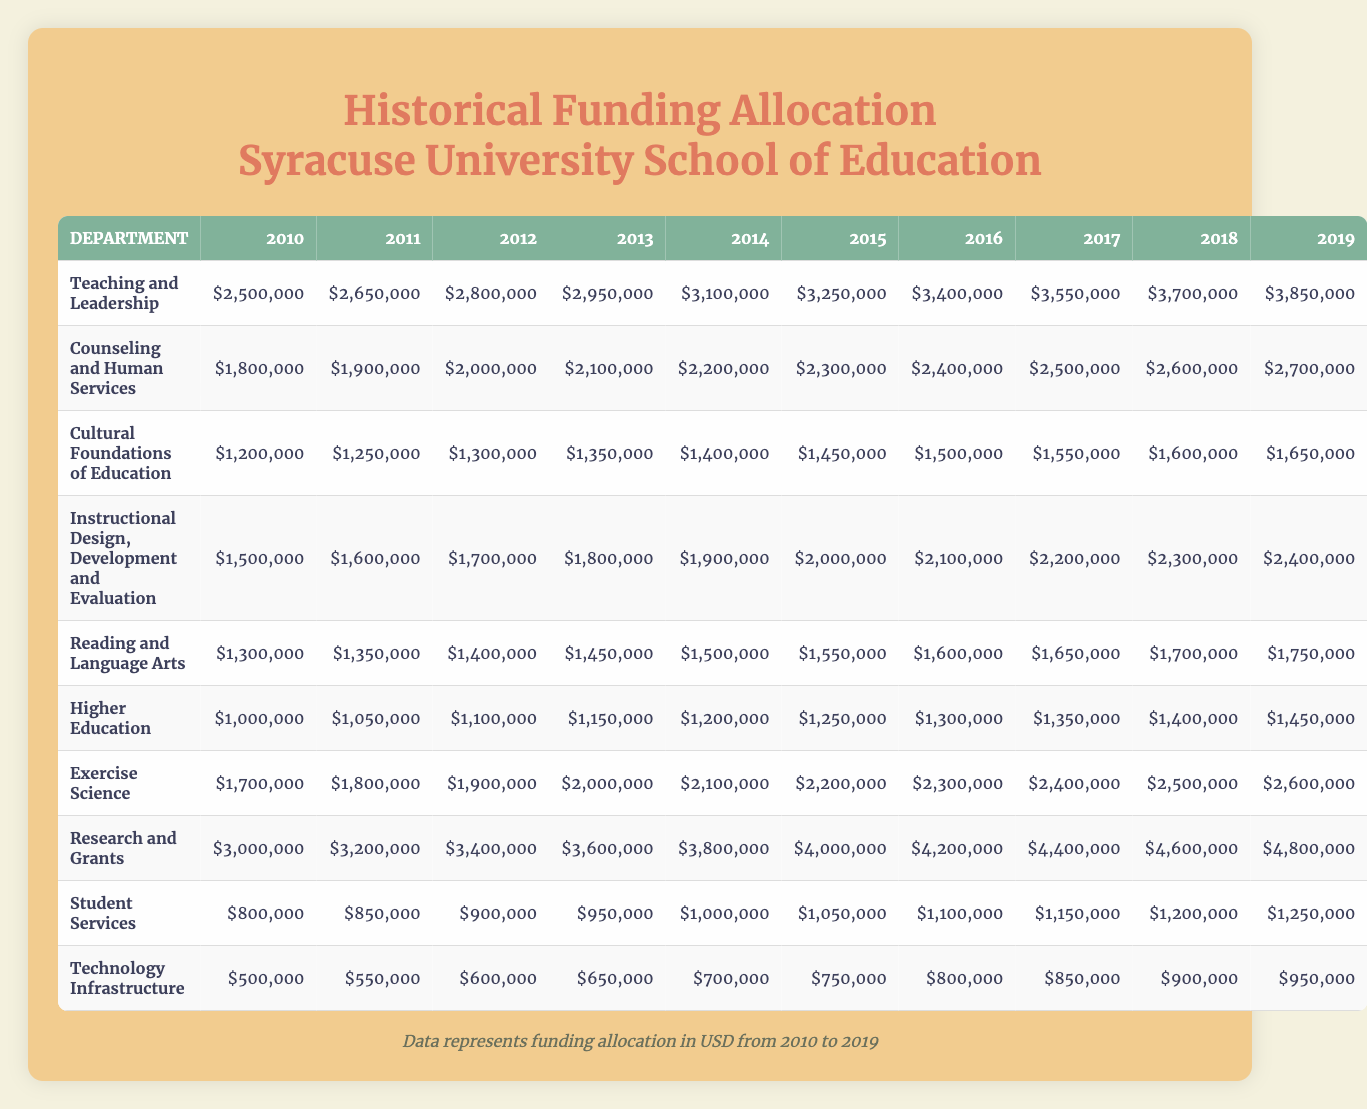What was the funding allocated to the Counseling and Human Services department in 2015? In 2015, the Counseling and Human Services department received $2,300,000 as seen in the corresponding row for that year.
Answer: $2,300,000 Which department received the highest funding in 2019? By comparing the funding allocations for all departments in 2019, Research and Grants received $4,800,000, which is higher than any other department's funding.
Answer: Research and Grants What is the total funding allocation for Teaching and Leadership from 2010 to 2019? Summing the allocations from 2010 to 2019 gives $2,500,000 + $2,650,000 + $2,800,000 + $2,950,000 + $3,100,000 + $3,250,000 + $3,400,000 + $3,550,000 + $3,700,000 + $3,850,000 = $30,800,000.
Answer: $30,800,000 Did the funding for Exercise Science increase every year from 2010 to 2019? Reviewing the data, Exercise Science shows an increase each year, starting at $1,700,000 in 2010 and reaching $2,600,000 in 2019.
Answer: Yes What was the average funding for the Cultural Foundations of Education department over the 10 years? The allocations are $1,200,000 + $1,250,000 + $1,300,000 + $1,350,000 + $1,400,000 + $1,450,000 + $1,500,000 + $1,550,000 + $1,600,000 + $1,650,000. The total is $13,800,000, divided by 10 years gives an average of $1,380,000.
Answer: $1,380,000 In which year did Higher Education see its first increase in funding? Looking at the funding amounts, Higher Education started at $1,000,000 in 2010 and increased to $1,050,000 in 2011, indicating the first increase occurred in 2011.
Answer: 2011 What is the difference in funding allocation between the highest and lowest funded departments in 2018? In 2018, Research and Grants received $4,600,000 and Technology Infrastructure received $900,000. The difference is $4,600,000 - $900,000 = $3,700,000.
Answer: $3,700,000 Which department had a consistent increase of at least $100,000 each year from 2010 to 2019? Evaluating each department, all departments except for Technology Infrastructure and Higher Education had consistent increases of more than $100,000 each year from 2010 to 2019.
Answer: Multiple departments (excluding Technology Infrastructure and Higher Education) How much total funding was allocated to Student Services over the ten years? Adding the yearly allocations: $800,000 + $850,000 + $900,000 + $950,000 + $1,000,000 + $1,050,000 + $1,100,000 + $1,150,000 + $1,200,000 + $1,250,000 = $10,200,000.
Answer: $10,200,000 In which year did the funding for Reading and Language Arts exceed $1,500,000 for the first time? The funding was $1,300,000 in 2010, then increases each year, exceeding $1,500,000 for the first time in 2014 when it was $1,500,000.
Answer: 2014 